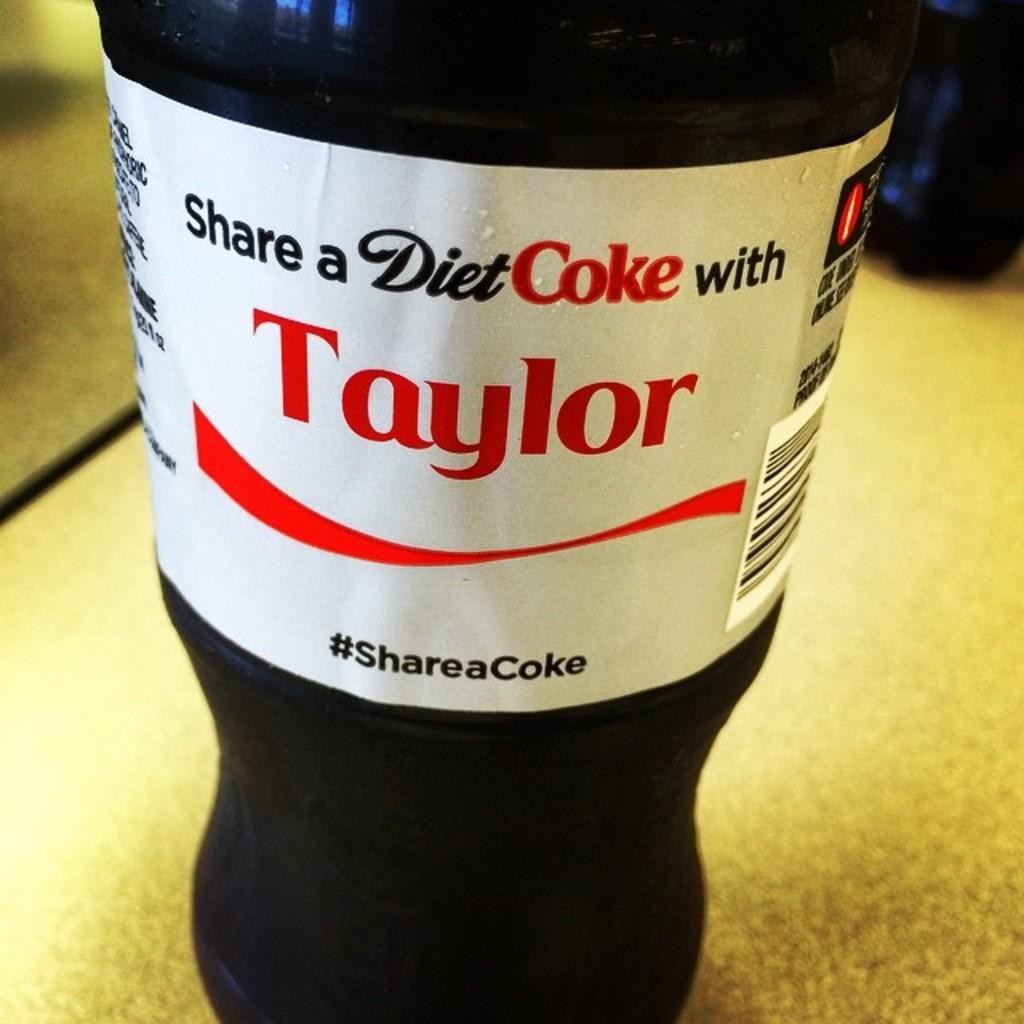What is on the table in the image? There is a Diet Coke bottle on a table. Can you describe the Diet Coke bottle? The Diet Coke bottle has a white sticker on it. Are there any other bottles visible in the image? Yes, there is another bottle visible in the image. What type of silk fabric is draped over the Diet Coke bottle in the image? There is no silk fabric present in the image; it only features a Diet Coke bottle with a white sticker on it and another bottle. 